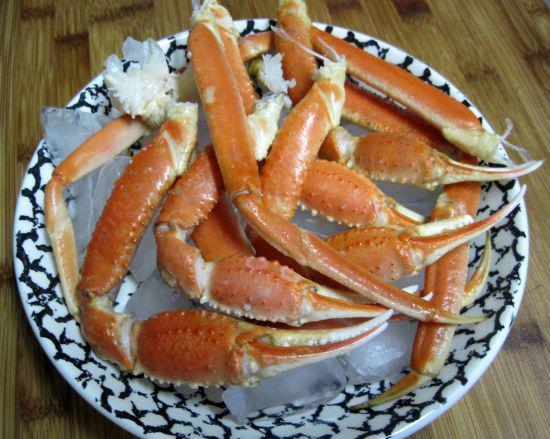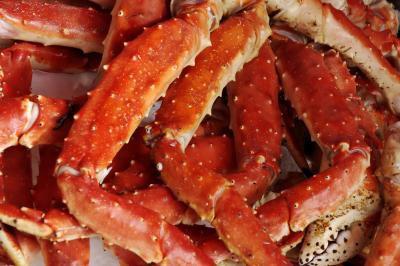The first image is the image on the left, the second image is the image on the right. Given the left and right images, does the statement "There is food other than crab in both images." hold true? Answer yes or no. No. The first image is the image on the left, the second image is the image on the right. For the images displayed, is the sentence "At least one of the images includes a small white dish of dipping sauce next to the plate of crab." factually correct? Answer yes or no. No. 